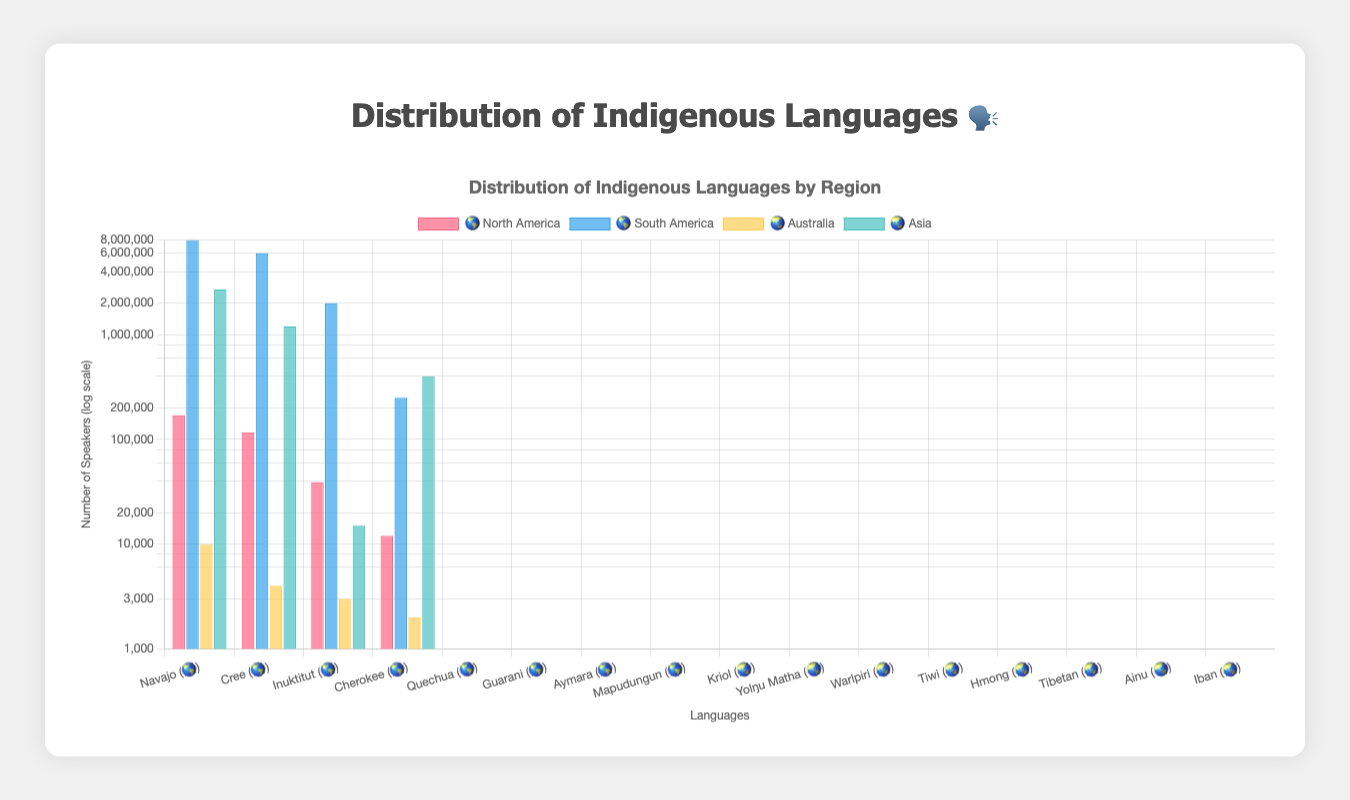Which region has the language with the most speakers? By examining the highest bars, Quechua in South America shows the largest number of speakers.
Answer: South America Which language in North America has the fewest speakers? Looking at the bars for North America, Cherokee has the smallest height.
Answer: Cherokee What is the approximate total number of speakers of indigenous languages in Australia? Summing the bars for Kriol, Yolŋu Matha, Warlpiri, and Tiwi: 10000 + 4000 + 3000 + 2000 = 19000
Answer: 19000 How many more speakers does Hmong in Asia have than Aymara in South America? Subtracting the speakers of Aymara (2000000) from Hmong (2700000): 2700000 - 2000000 = 700000
Answer: 700000 Compare the number of speakers of Cree in North America and Tibetan in Asia. Which one has more speakers? By comparing the bar heights of Cree (117000) and Tibetan (1200000), Tibetan has more speakers.
Answer: Tibetan What is the average number of speakers for the four languages in North America? Adding the speakers of Navajo, Cree, Inuktitut, and Cherokee and dividing by 4: (170000 + 117000 + 39000 + 12000) / 4 = 84500
Answer: 84500 Does Australia or North America have a higher number of total language speakers? Summing speakers in each region: Australia 19000 vs. North America (170000 + 117000 + 39000 + 12000 = 338000). Clearly, North America has more.
Answer: North America Which language has the second highest number of speakers in South America? Looking at the South America section, the second tallest bar after Quechua is Guarani.
Answer: Guarani What is the ratio of the number of speakers of Navajo to Tiwi? Dividing the number of speakers of Navajo by the speakers of Tiwi: 170000 / 2000 = 85
Answer: 85 Identify the languages present in Asia and their respective number of speakers. Observing the Asian region, the languages and their speakers are Hmong (2700000), Tibetan (1200000), Ainu (15000), Iban (400000).
Answer: Hmong: 2700000, Tibetan: 1200000, Ainu: 15000, Iban: 400000 